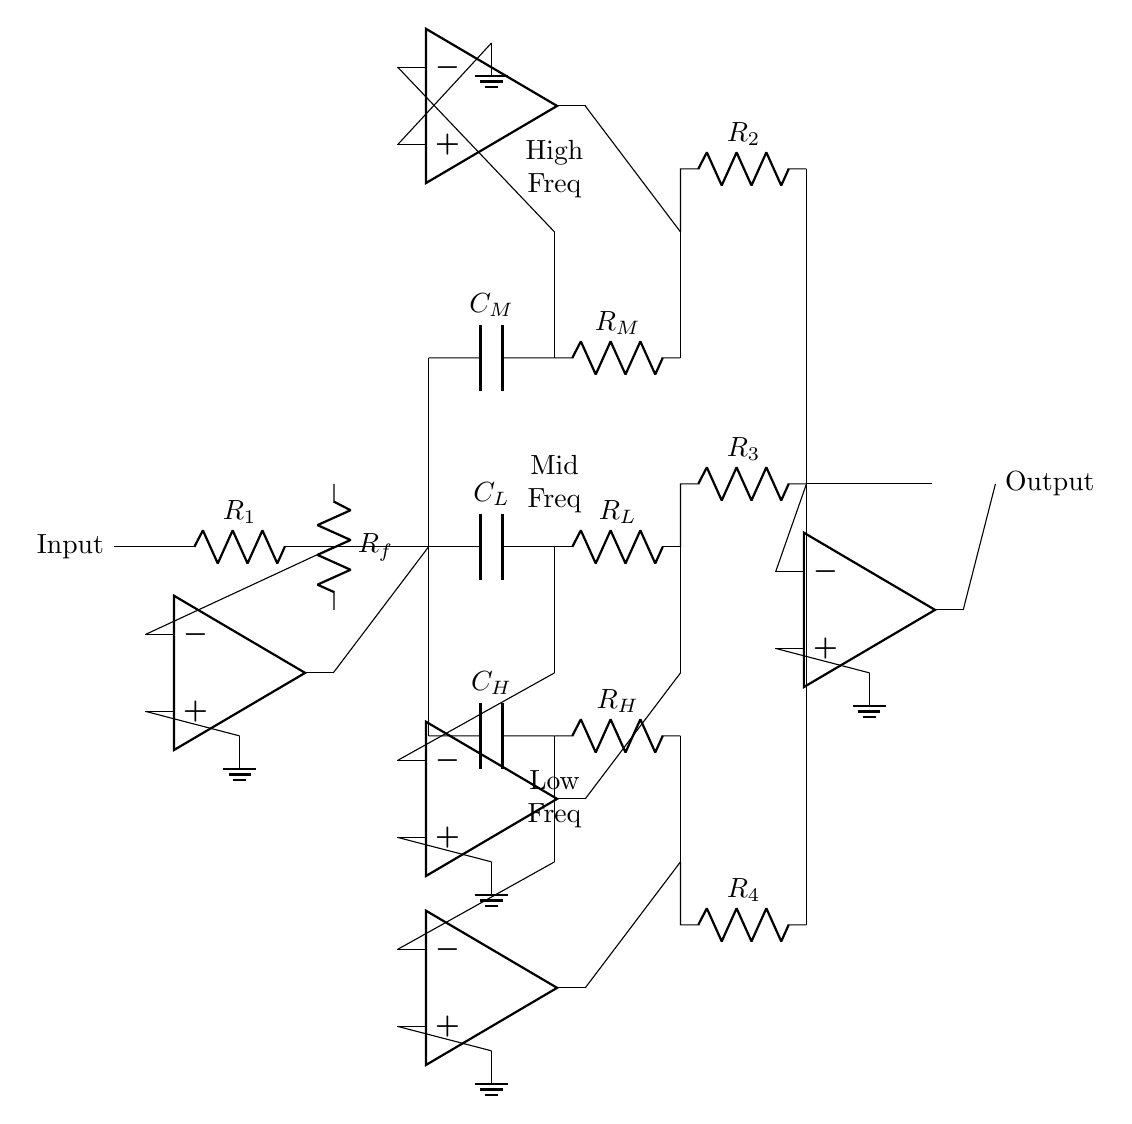What type of circuit is shown? The circuit is an audio equalizer circuit designed for adjusting sound across different frequency bands. This can be identified by the multiple op-amps and passive components configured to handle low, mid, and high frequency bands.
Answer: Audio equalizer What is the function of R1? R1 is the input resistor that helps set the gain of the first op-amp stage by defining the input impedance and stabilizing the signal before amplification.
Answer: Input resistor How many op-amps are present in the circuit? The circuit contains four op-amps, one for each frequency band and one summing amplifier for the final output stage. You can count the distinct op-amps drawn in the diagram.
Answer: Four What does C_L represent in the circuit? C_L is the capacitor connected to the low-frequency band, designed to filter and allow low frequencies to pass through while blocking higher frequencies.
Answer: Capacitor for low frequency Which component determines the high frequency response in the circuit? R_H combined with C_H determines the high frequency response, as they form a high-pass filter that allows high frequencies to pass while attenuating lower frequencies.
Answer: R_H and C_H What is the role of the summing op-amp in the circuit? The summing op-amp takes the outputs from the different frequency bands and combines them into a single output signal. This is crucial for producing a full-range audio output based on user adjustments.
Answer: Combine outputs What is the purpose of C_M in the circuit? C_M is the capacitor used in the mid-frequency band, serving to filter and enhance the mid-range frequencies for better clarity in sound reproduction.
Answer: Capacitor for mid frequency 